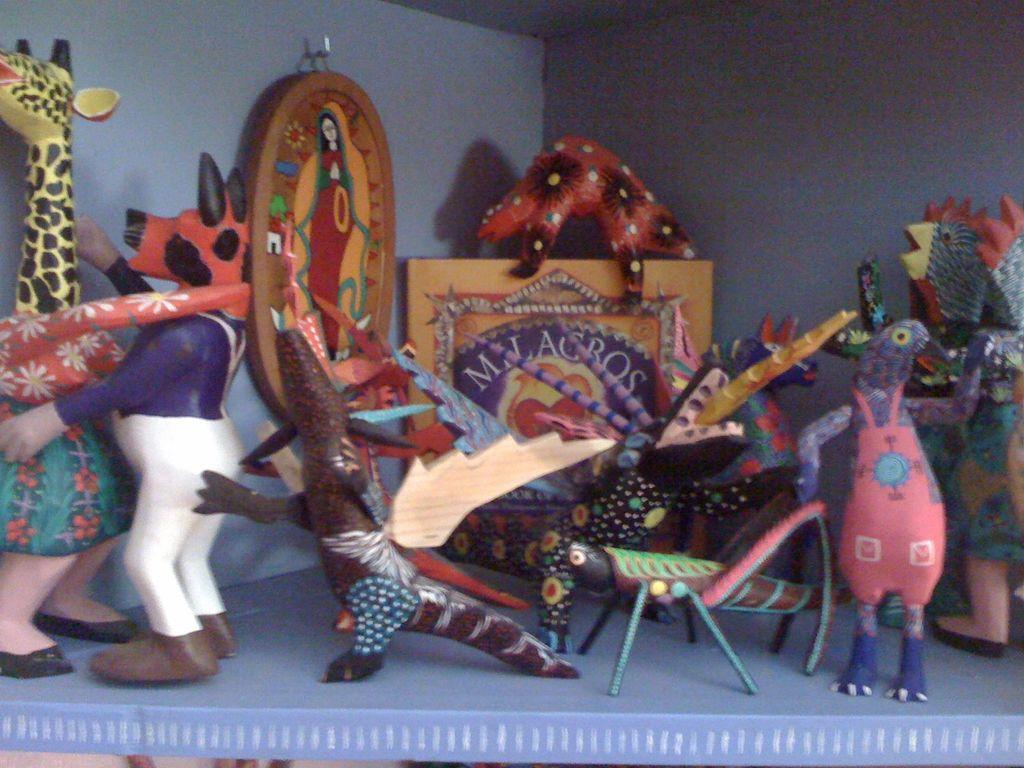How would you summarize this image in a sentence or two? In the picture I can see many toys are placed on the blue color surface and I can see some frame hanged to the wall. 